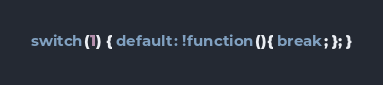<code> <loc_0><loc_0><loc_500><loc_500><_JavaScript_>switch(1) { default: !function(){ break; }; }</code> 